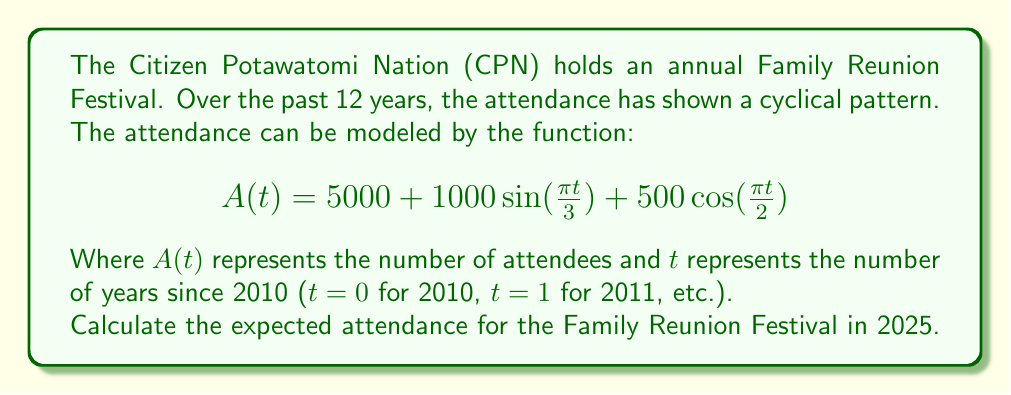Could you help me with this problem? To solve this problem, we need to follow these steps:

1. Identify the year we're calculating for:
   2025 is 15 years after 2010, so t = 15

2. Substitute t = 15 into the given function:
   $$A(15) = 5000 + 1000\sin(\frac{\pi \cdot 15}{3}) + 500\cos(\frac{\pi \cdot 15}{2})$$

3. Simplify the arguments of the trigonometric functions:
   $$A(15) = 5000 + 1000\sin(5\pi) + 500\cos(\frac{15\pi}{2})$$

4. Evaluate the trigonometric functions:
   $\sin(5\pi) = 0$ (since sine has a period of $2\pi$)
   $\cos(\frac{15\pi}{2}) = \cos(\frac{\pi}{2}) = 0$ (since $15\pi/2 = 7\pi + \pi/2$, and cosine has a period of $2\pi$)

5. Substitute these values and calculate:
   $$A(15) = 5000 + 1000(0) + 500(0) = 5000$$

Therefore, the expected attendance for the Family Reunion Festival in 2025 is 5000 people.
Answer: 5000 attendees 